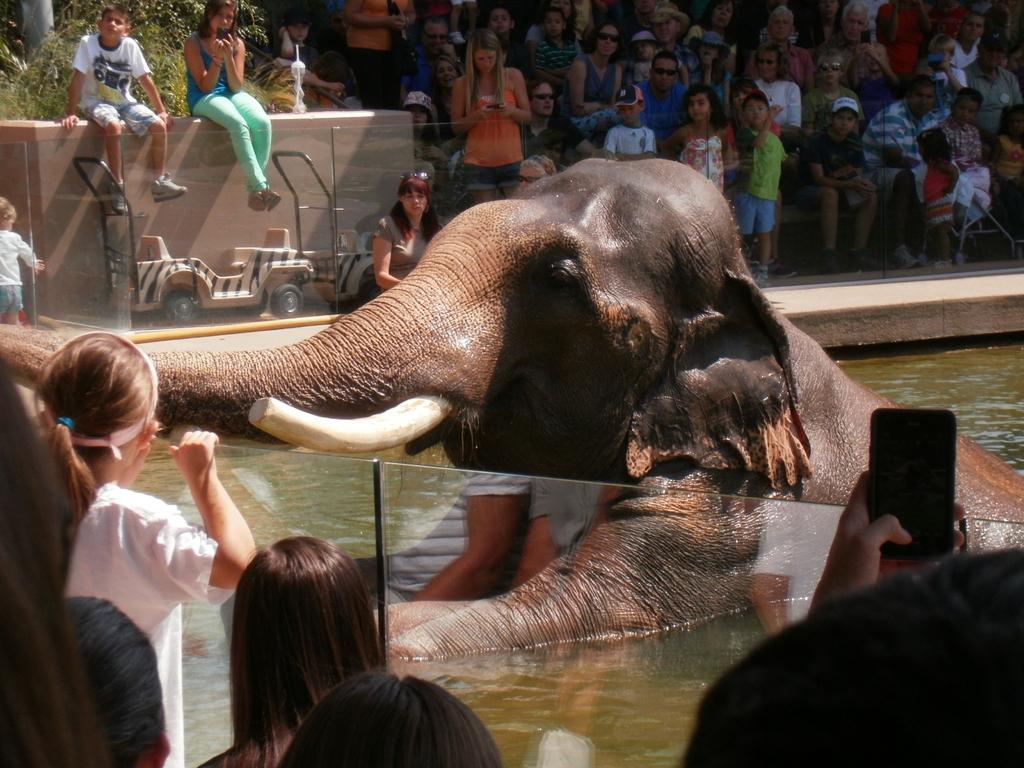How would you summarize this image in a sentence or two? Here there is an elephant in the water. It has a white color trunk and long ears. If you observe on the right side of an image there is a person shooting elephant actions with the phone and left side of an image you could observe there are some kids observing the elephant and here is a girl. She wore a white color T-Shirt she has a hair ribbon and elephant is in the water If you look at this side there is a vehicle which is used for travelling the people on this site. And if you look at their. There are two kids observing the elephant by sitting on the wall behind them there are some bushes. And coming to this side there are people who are sitting and watching the elephant from there. Here the kid wore a cap and the woman who is looking mobile phone. 